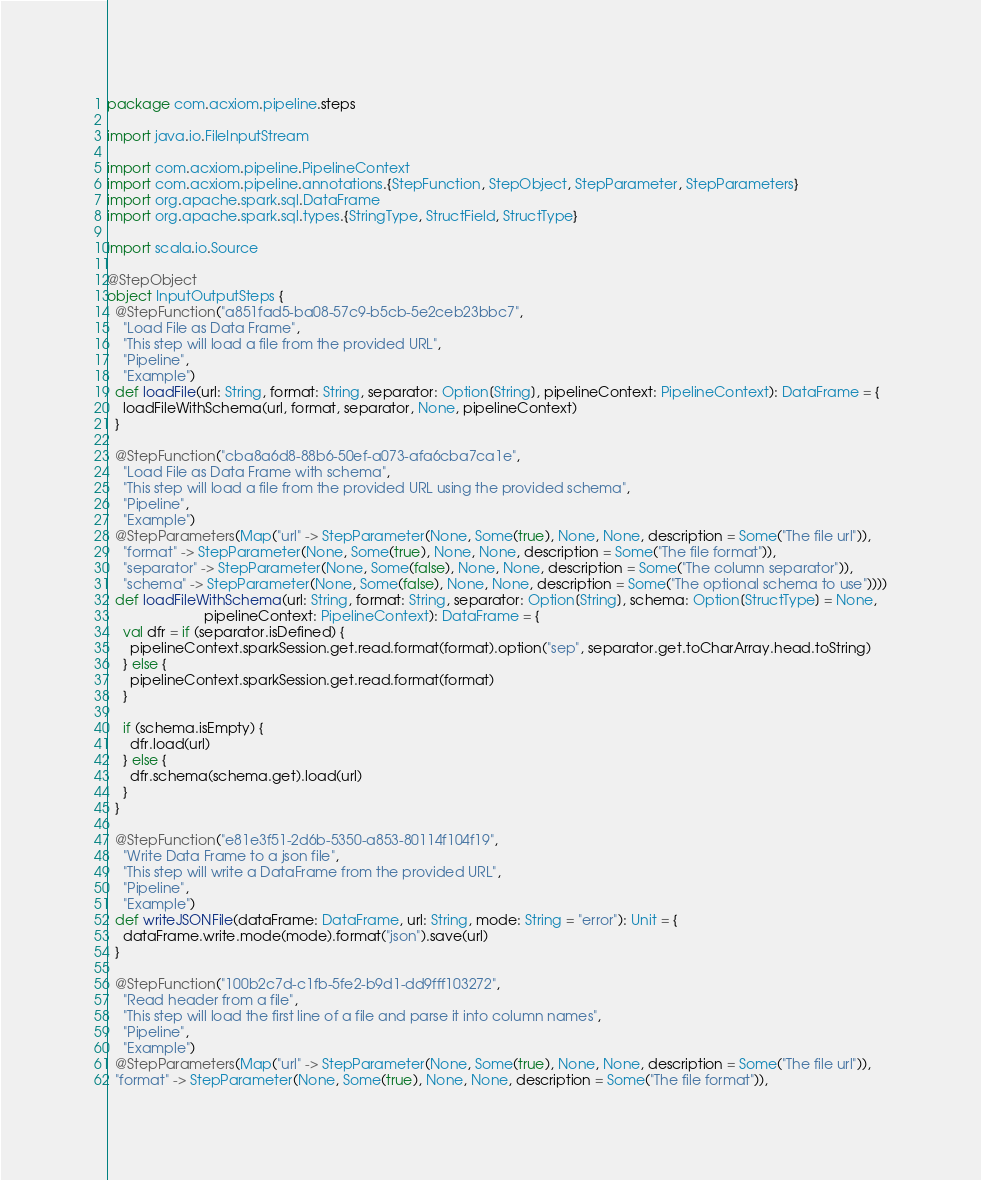<code> <loc_0><loc_0><loc_500><loc_500><_Scala_>package com.acxiom.pipeline.steps

import java.io.FileInputStream

import com.acxiom.pipeline.PipelineContext
import com.acxiom.pipeline.annotations.{StepFunction, StepObject, StepParameter, StepParameters}
import org.apache.spark.sql.DataFrame
import org.apache.spark.sql.types.{StringType, StructField, StructType}

import scala.io.Source

@StepObject
object InputOutputSteps {
  @StepFunction("a851fad5-ba08-57c9-b5cb-5e2ceb23bbc7",
    "Load File as Data Frame",
    "This step will load a file from the provided URL",
    "Pipeline",
    "Example")
  def loadFile(url: String, format: String, separator: Option[String], pipelineContext: PipelineContext): DataFrame = {
    loadFileWithSchema(url, format, separator, None, pipelineContext)
  }

  @StepFunction("cba8a6d8-88b6-50ef-a073-afa6cba7ca1e",
    "Load File as Data Frame with schema",
    "This step will load a file from the provided URL using the provided schema",
    "Pipeline",
    "Example")
  @StepParameters(Map("url" -> StepParameter(None, Some(true), None, None, description = Some("The file url")),
    "format" -> StepParameter(None, Some(true), None, None, description = Some("The file format")),
    "separator" -> StepParameter(None, Some(false), None, None, description = Some("The column separator")),
    "schema" -> StepParameter(None, Some(false), None, None, description = Some("The optional schema to use"))))
  def loadFileWithSchema(url: String, format: String, separator: Option[String], schema: Option[StructType] = None,
                         pipelineContext: PipelineContext): DataFrame = {
    val dfr = if (separator.isDefined) {
      pipelineContext.sparkSession.get.read.format(format).option("sep", separator.get.toCharArray.head.toString)
    } else {
      pipelineContext.sparkSession.get.read.format(format)
    }

    if (schema.isEmpty) {
      dfr.load(url)
    } else {
      dfr.schema(schema.get).load(url)
    }
  }

  @StepFunction("e81e3f51-2d6b-5350-a853-80114f104f19",
    "Write Data Frame to a json file",
    "This step will write a DataFrame from the provided URL",
    "Pipeline",
    "Example")
  def writeJSONFile(dataFrame: DataFrame, url: String, mode: String = "error"): Unit = {
    dataFrame.write.mode(mode).format("json").save(url)
  }

  @StepFunction("100b2c7d-c1fb-5fe2-b9d1-dd9fff103272",
    "Read header from a file",
    "This step will load the first line of a file and parse it into column names",
    "Pipeline",
    "Example")
  @StepParameters(Map("url" -> StepParameter(None, Some(true), None, None, description = Some("The file url")),
  "format" -> StepParameter(None, Some(true), None, None, description = Some("The file format")),</code> 